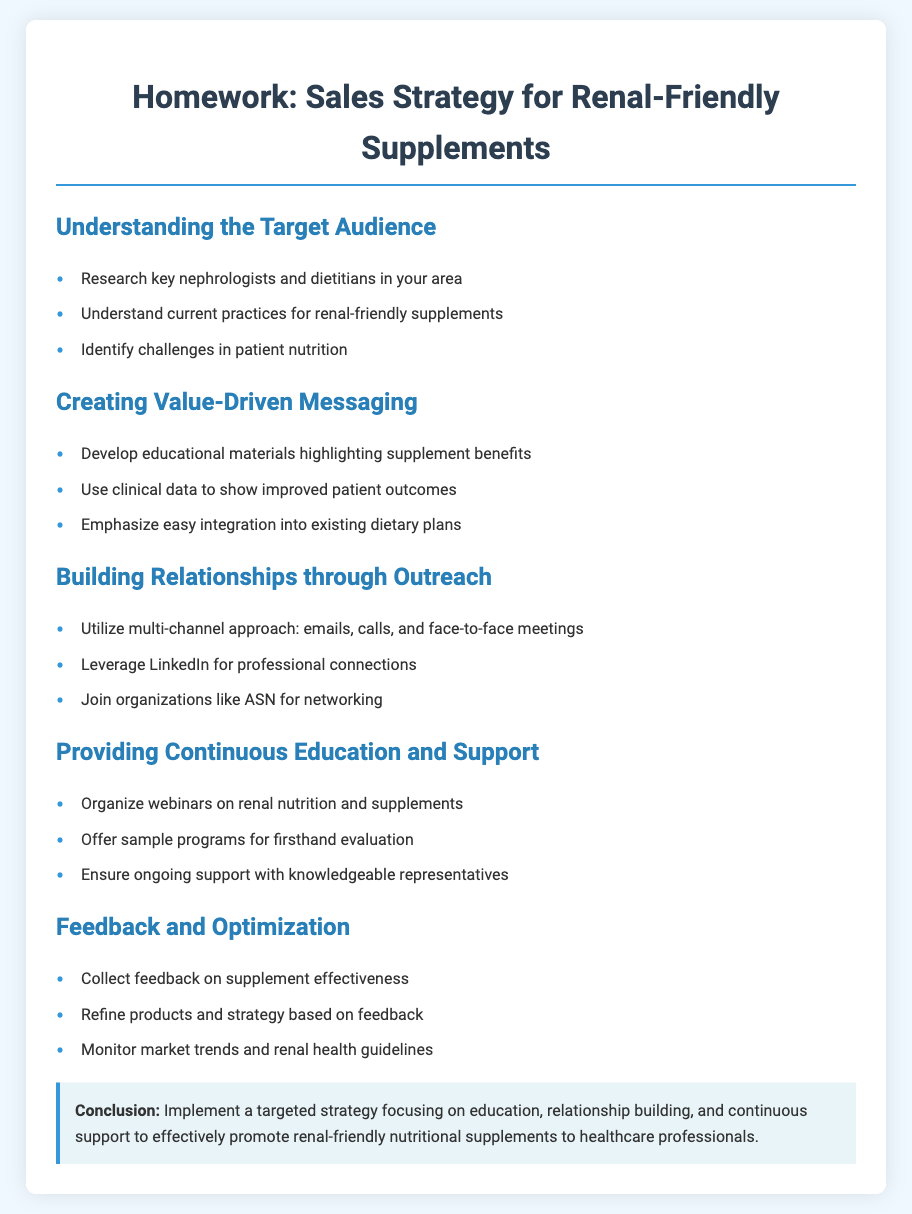What is the primary goal of the homework? The homework aims to develop a sales strategy for promoting renal-friendly nutritional supplements.
Answer: to develop a sales strategy Who is the target audience for the sales strategy? The target audience includes nephrologists and dietitians.
Answer: nephrologists and dietitians What is one method suggested for building relationships? One method suggested is using a multi-channel approach, including emails, calls, and meetings.
Answer: multi-channel approach What organization is mentioned for networking opportunities? The organization mentioned for networking is ASN.
Answer: ASN Which educational activity is recommended to provide ongoing support? The recommended educational activity is organizing webinars on renal nutrition and supplements.
Answer: webinars What should be emphasized in value-driven messaging? The messaging should emphasize easy integration into existing dietary plans.
Answer: easy integration How many key areas are outlined in the homework? There are five key areas outlined in the homework.
Answer: five What is one action suggested for collecting feedback? One action suggested is to collect feedback on supplement effectiveness.
Answer: collect feedback What type of materials should be developed for nephrologists and dietitians? Educational materials highlighting supplement benefits should be developed.
Answer: educational materials 